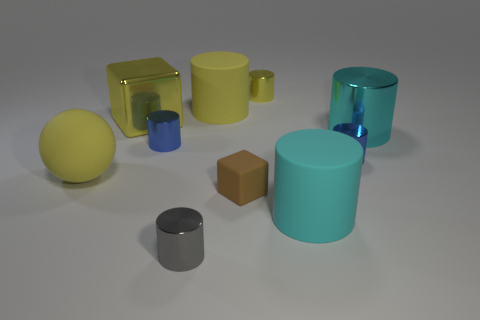The brown object that is the same size as the gray metallic cylinder is what shape?
Ensure brevity in your answer.  Cube. What number of tiny brown matte things are behind the big shiny cube?
Your response must be concise. 0. What number of things are either cylinders or big gray metal things?
Offer a very short reply. 7. There is a big matte thing that is in front of the big yellow metal thing and behind the small block; what is its shape?
Your answer should be very brief. Sphere. How many brown matte blocks are there?
Offer a very short reply. 1. There is a large ball that is made of the same material as the tiny brown thing; what color is it?
Your answer should be compact. Yellow. Are there more yellow rubber spheres than yellow rubber objects?
Keep it short and to the point. No. How big is the cylinder that is both in front of the tiny rubber cube and behind the tiny gray metallic thing?
Give a very brief answer. Large. What is the material of the small cylinder that is the same color as the rubber ball?
Provide a short and direct response. Metal. Is the number of tiny blue objects on the right side of the cyan matte thing the same as the number of big brown balls?
Make the answer very short. No. 